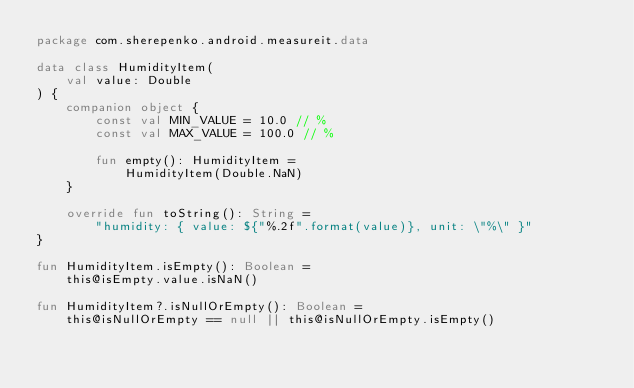Convert code to text. <code><loc_0><loc_0><loc_500><loc_500><_Kotlin_>package com.sherepenko.android.measureit.data

data class HumidityItem(
    val value: Double
) {
    companion object {
        const val MIN_VALUE = 10.0 // %
        const val MAX_VALUE = 100.0 // %

        fun empty(): HumidityItem =
            HumidityItem(Double.NaN)
    }

    override fun toString(): String =
        "humidity: { value: ${"%.2f".format(value)}, unit: \"%\" }"
}

fun HumidityItem.isEmpty(): Boolean =
    this@isEmpty.value.isNaN()

fun HumidityItem?.isNullOrEmpty(): Boolean =
    this@isNullOrEmpty == null || this@isNullOrEmpty.isEmpty()
</code> 